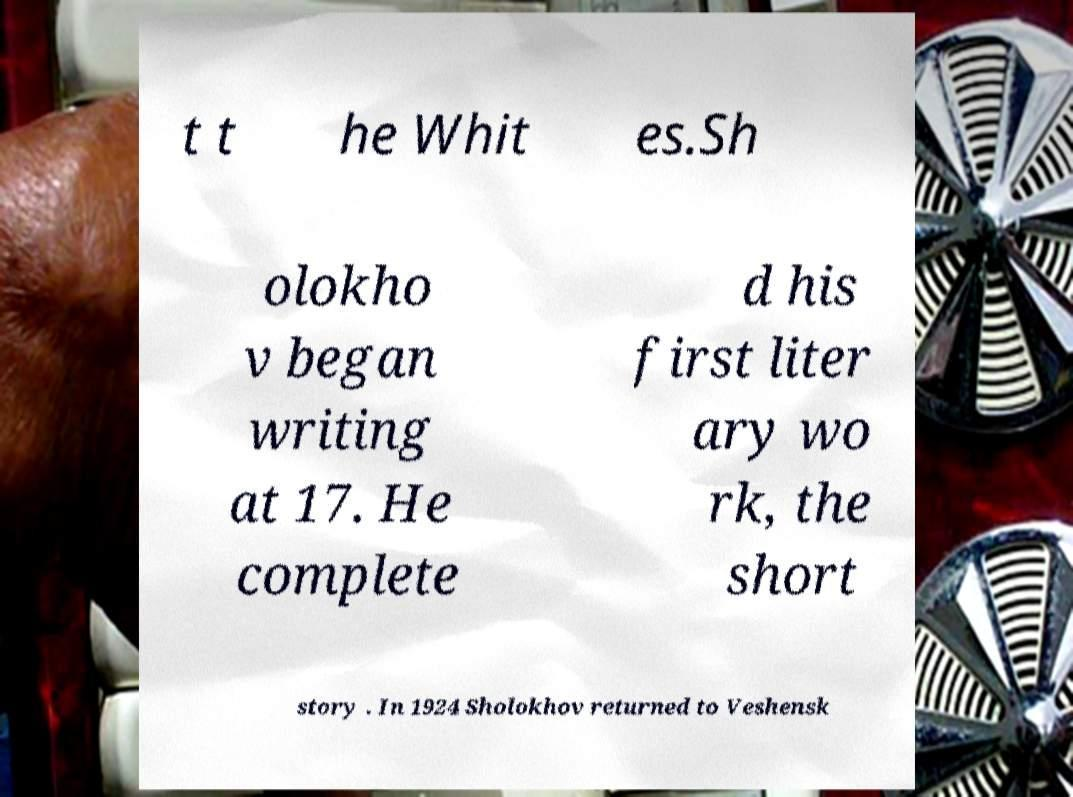For documentation purposes, I need the text within this image transcribed. Could you provide that? t t he Whit es.Sh olokho v began writing at 17. He complete d his first liter ary wo rk, the short story . In 1924 Sholokhov returned to Veshensk 